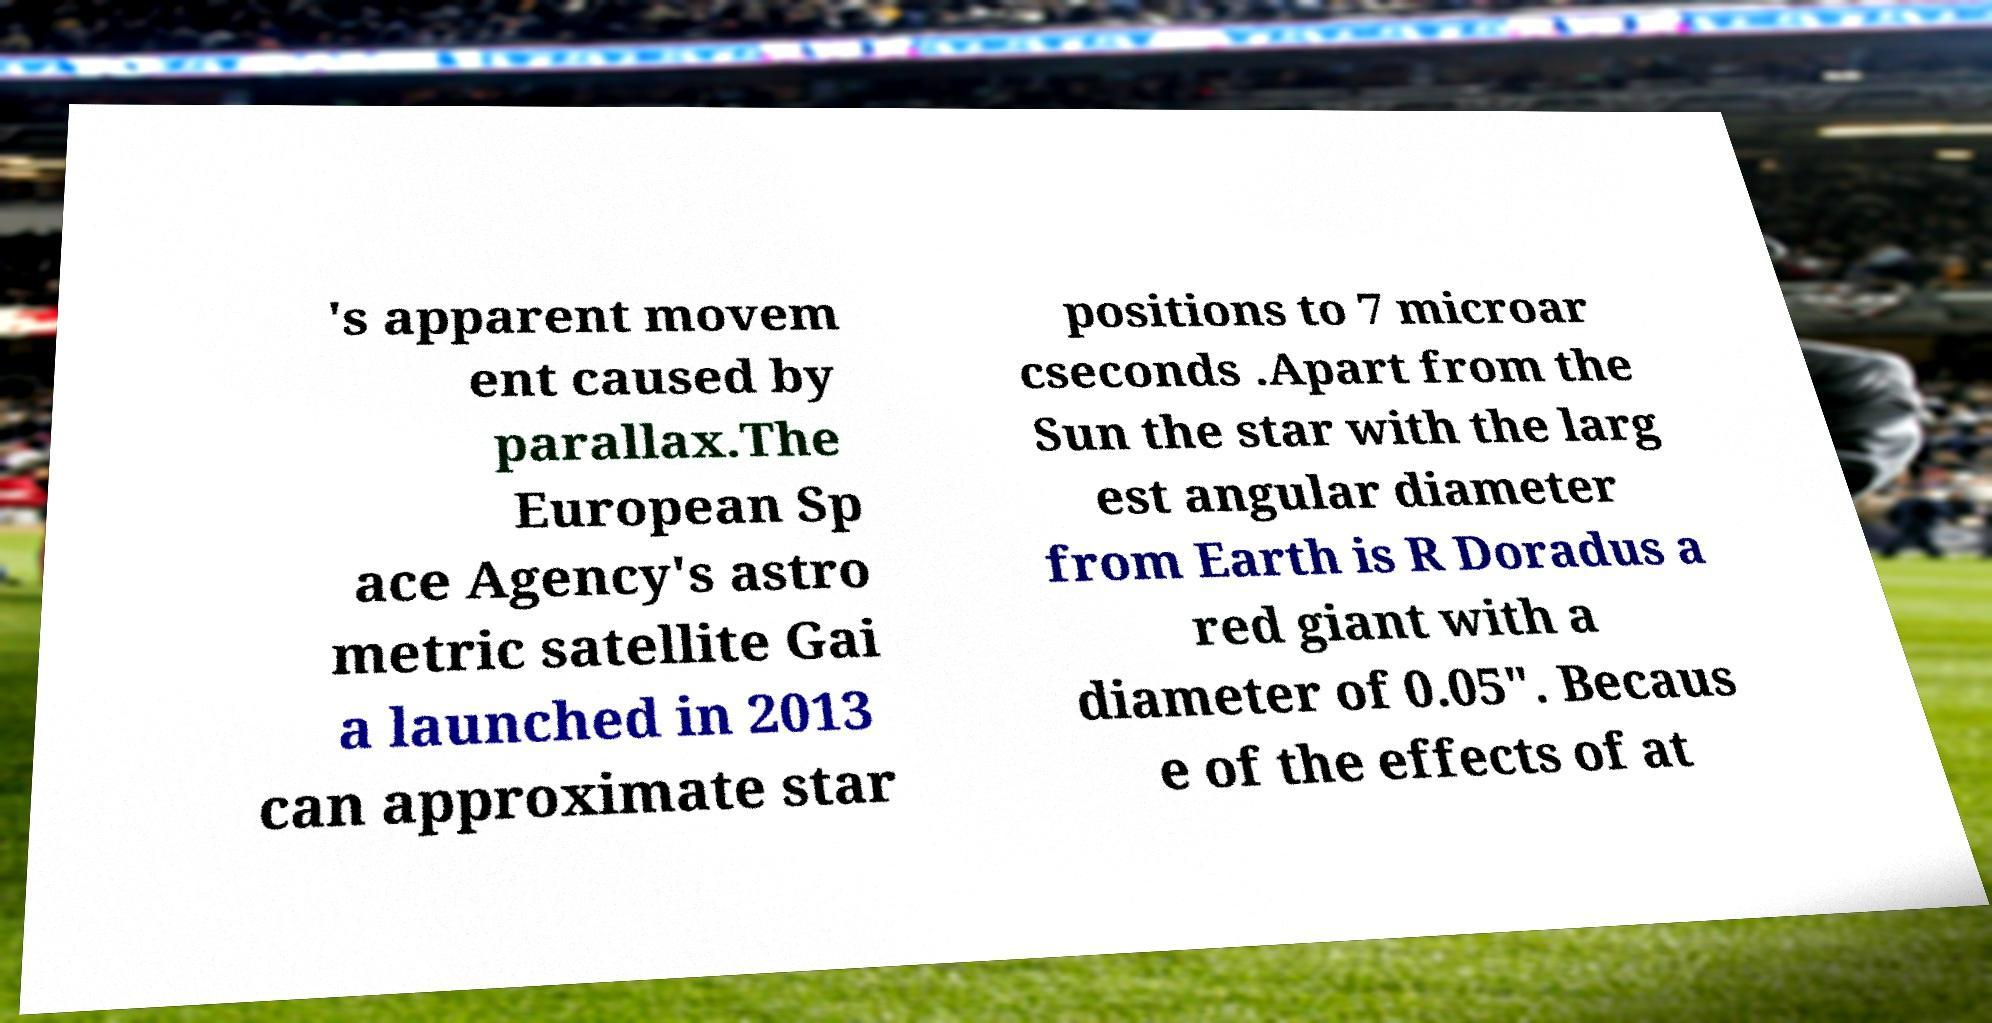What messages or text are displayed in this image? I need them in a readable, typed format. 's apparent movem ent caused by parallax.The European Sp ace Agency's astro metric satellite Gai a launched in 2013 can approximate star positions to 7 microar cseconds .Apart from the Sun the star with the larg est angular diameter from Earth is R Doradus a red giant with a diameter of 0.05″. Becaus e of the effects of at 